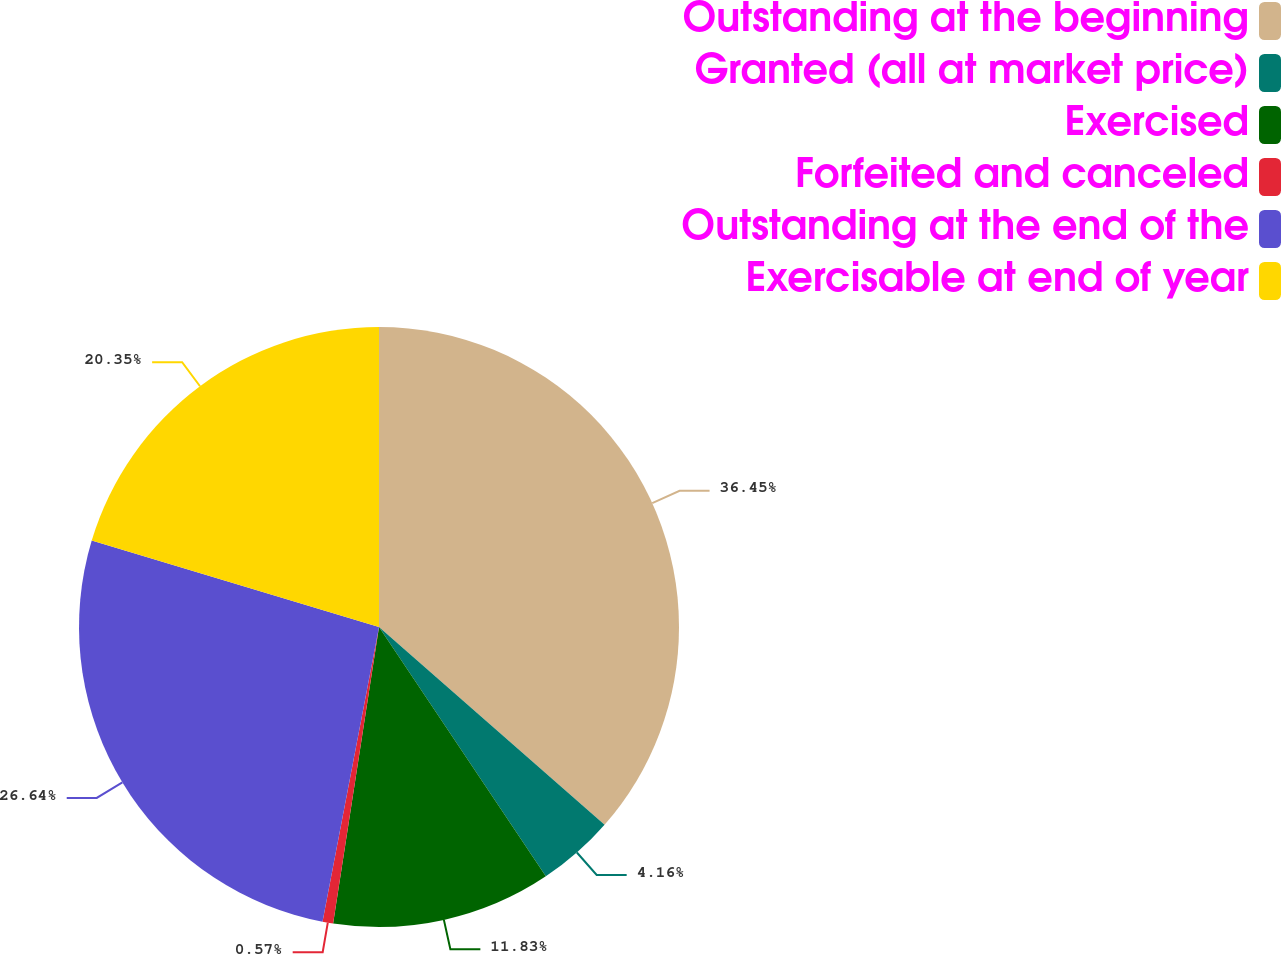Convert chart. <chart><loc_0><loc_0><loc_500><loc_500><pie_chart><fcel>Outstanding at the beginning<fcel>Granted (all at market price)<fcel>Exercised<fcel>Forfeited and canceled<fcel>Outstanding at the end of the<fcel>Exercisable at end of year<nl><fcel>36.46%<fcel>4.16%<fcel>11.83%<fcel>0.57%<fcel>26.64%<fcel>20.35%<nl></chart> 